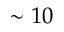Convert formula to latex. <formula><loc_0><loc_0><loc_500><loc_500>\sim 1 0</formula> 